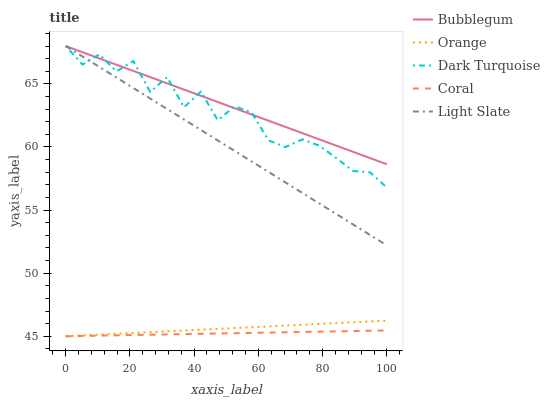Does Coral have the minimum area under the curve?
Answer yes or no. Yes. Does Bubblegum have the maximum area under the curve?
Answer yes or no. Yes. Does Dark Turquoise have the minimum area under the curve?
Answer yes or no. No. Does Dark Turquoise have the maximum area under the curve?
Answer yes or no. No. Is Orange the smoothest?
Answer yes or no. Yes. Is Dark Turquoise the roughest?
Answer yes or no. Yes. Is Coral the smoothest?
Answer yes or no. No. Is Coral the roughest?
Answer yes or no. No. Does Orange have the lowest value?
Answer yes or no. Yes. Does Dark Turquoise have the lowest value?
Answer yes or no. No. Does Bubblegum have the highest value?
Answer yes or no. Yes. Does Coral have the highest value?
Answer yes or no. No. Is Coral less than Dark Turquoise?
Answer yes or no. Yes. Is Bubblegum greater than Coral?
Answer yes or no. Yes. Does Orange intersect Coral?
Answer yes or no. Yes. Is Orange less than Coral?
Answer yes or no. No. Is Orange greater than Coral?
Answer yes or no. No. Does Coral intersect Dark Turquoise?
Answer yes or no. No. 